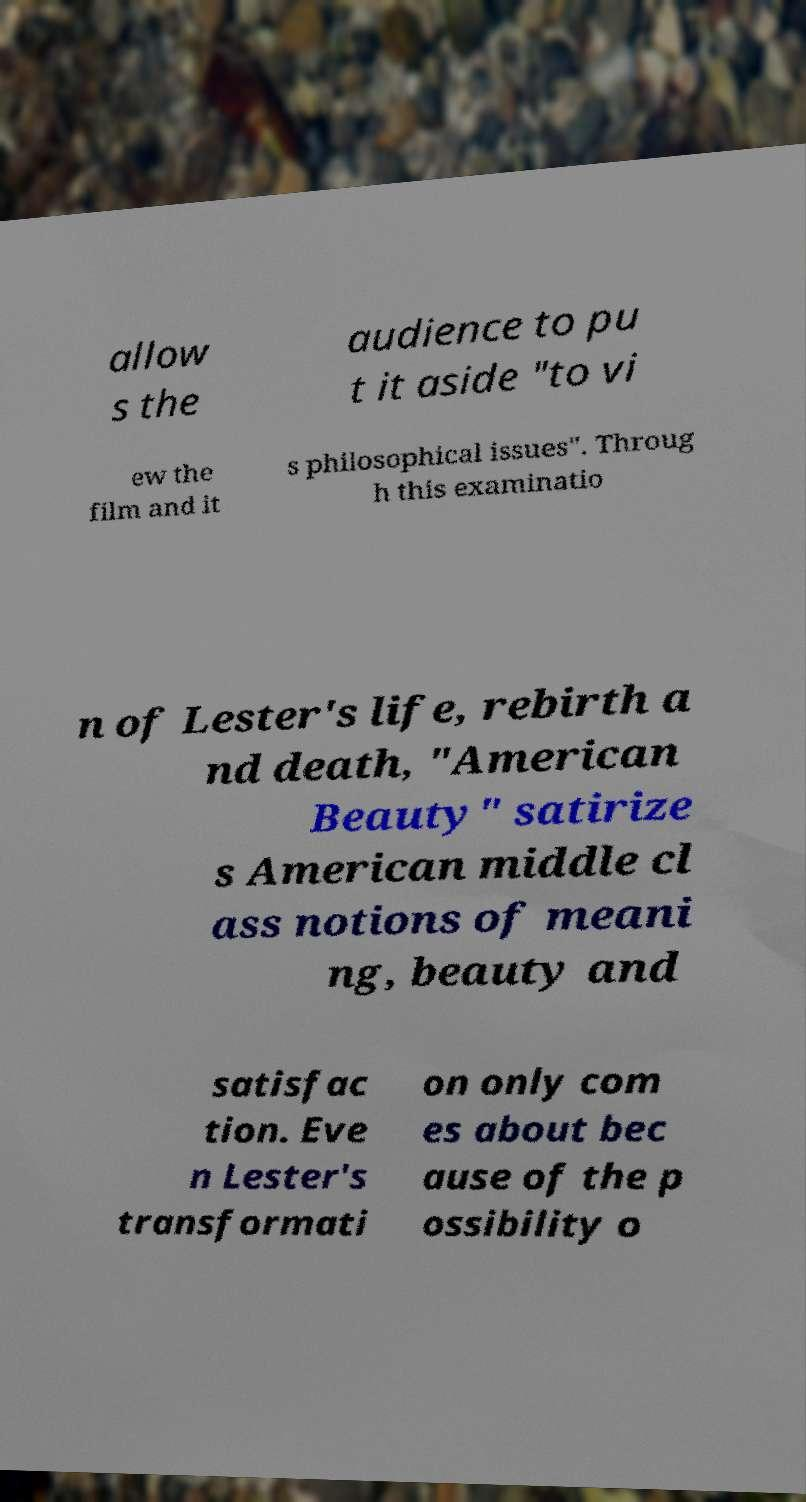Can you read and provide the text displayed in the image?This photo seems to have some interesting text. Can you extract and type it out for me? allow s the audience to pu t it aside "to vi ew the film and it s philosophical issues". Throug h this examinatio n of Lester's life, rebirth a nd death, "American Beauty" satirize s American middle cl ass notions of meani ng, beauty and satisfac tion. Eve n Lester's transformati on only com es about bec ause of the p ossibility o 